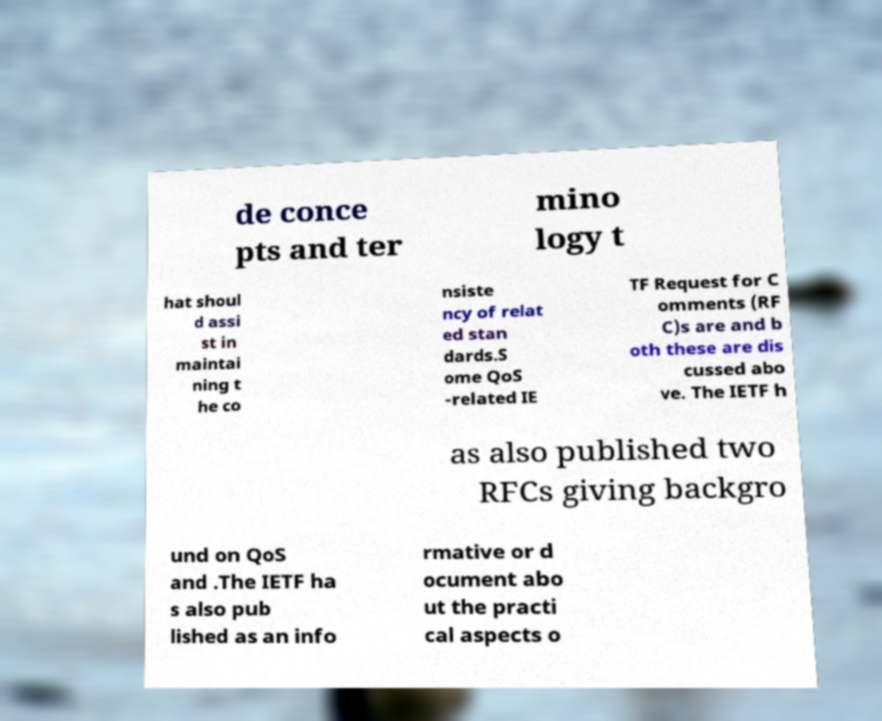Could you assist in decoding the text presented in this image and type it out clearly? de conce pts and ter mino logy t hat shoul d assi st in maintai ning t he co nsiste ncy of relat ed stan dards.S ome QoS -related IE TF Request for C omments (RF C)s are and b oth these are dis cussed abo ve. The IETF h as also published two RFCs giving backgro und on QoS and .The IETF ha s also pub lished as an info rmative or d ocument abo ut the practi cal aspects o 